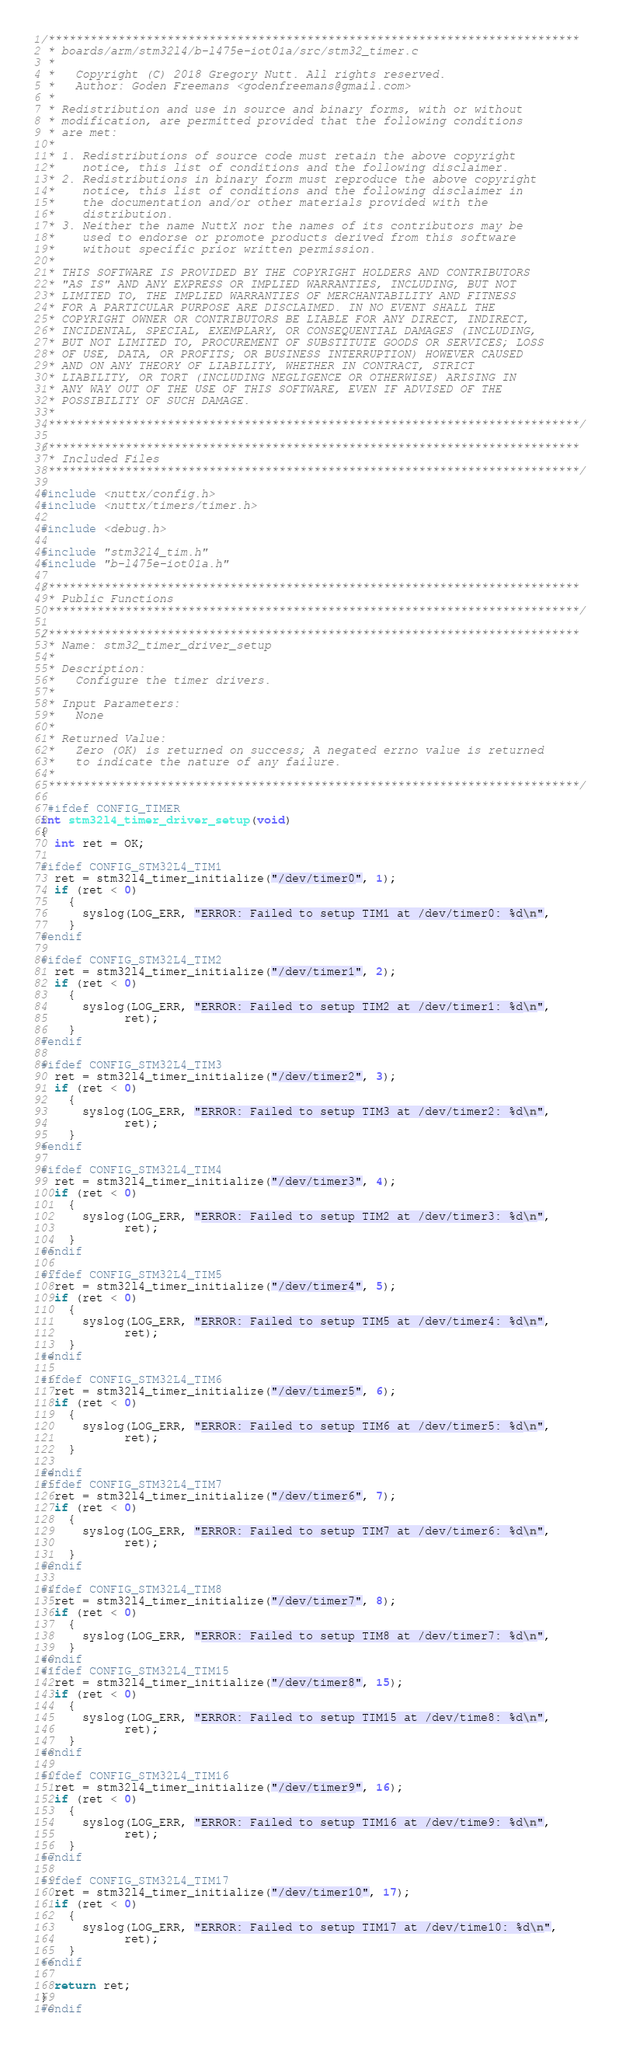<code> <loc_0><loc_0><loc_500><loc_500><_C_>/****************************************************************************
 * boards/arm/stm32l4/b-l475e-iot01a/src/stm32_timer.c
 *
 *   Copyright (C) 2018 Gregory Nutt. All rights reserved.
 *   Author: Goden Freemans <godenfreemans@gmail.com>
 *
 * Redistribution and use in source and binary forms, with or without
 * modification, are permitted provided that the following conditions
 * are met:
 *
 * 1. Redistributions of source code must retain the above copyright
 *    notice, this list of conditions and the following disclaimer.
 * 2. Redistributions in binary form must reproduce the above copyright
 *    notice, this list of conditions and the following disclaimer in
 *    the documentation and/or other materials provided with the
 *    distribution.
 * 3. Neither the name NuttX nor the names of its contributors may be
 *    used to endorse or promote products derived from this software
 *    without specific prior written permission.
 *
 * THIS SOFTWARE IS PROVIDED BY THE COPYRIGHT HOLDERS AND CONTRIBUTORS
 * "AS IS" AND ANY EXPRESS OR IMPLIED WARRANTIES, INCLUDING, BUT NOT
 * LIMITED TO, THE IMPLIED WARRANTIES OF MERCHANTABILITY AND FITNESS
 * FOR A PARTICULAR PURPOSE ARE DISCLAIMED. IN NO EVENT SHALL THE
 * COPYRIGHT OWNER OR CONTRIBUTORS BE LIABLE FOR ANY DIRECT, INDIRECT,
 * INCIDENTAL, SPECIAL, EXEMPLARY, OR CONSEQUENTIAL DAMAGES (INCLUDING,
 * BUT NOT LIMITED TO, PROCUREMENT OF SUBSTITUTE GOODS OR SERVICES; LOSS
 * OF USE, DATA, OR PROFITS; OR BUSINESS INTERRUPTION) HOWEVER CAUSED
 * AND ON ANY THEORY OF LIABILITY, WHETHER IN CONTRACT, STRICT
 * LIABILITY, OR TORT (INCLUDING NEGLIGENCE OR OTHERWISE) ARISING IN
 * ANY WAY OUT OF THE USE OF THIS SOFTWARE, EVEN IF ADVISED OF THE
 * POSSIBILITY OF SUCH DAMAGE.
 *
 ****************************************************************************/

/****************************************************************************
 * Included Files
 ****************************************************************************/

#include <nuttx/config.h>
#include <nuttx/timers/timer.h>

#include <debug.h>

#include "stm32l4_tim.h"
#include "b-l475e-iot01a.h"

/****************************************************************************
 * Public Functions
 ****************************************************************************/

/****************************************************************************
 * Name: stm32_timer_driver_setup
 *
 * Description:
 *   Configure the timer drivers.
 *
 * Input Parameters:
 *   None
 *
 * Returned Value:
 *   Zero (OK) is returned on success; A negated errno value is returned
 *   to indicate the nature of any failure.
 *
 ****************************************************************************/

 #ifdef CONFIG_TIMER
int stm32l4_timer_driver_setup(void)
{
  int ret = OK;

#ifdef CONFIG_STM32L4_TIM1
  ret = stm32l4_timer_initialize("/dev/timer0", 1);
  if (ret < 0)
    {
      syslog(LOG_ERR, "ERROR: Failed to setup TIM1 at /dev/timer0: %d\n",
    }
#endif

#ifdef CONFIG_STM32L4_TIM2
  ret = stm32l4_timer_initialize("/dev/timer1", 2);
  if (ret < 0)
    {
      syslog(LOG_ERR, "ERROR: Failed to setup TIM2 at /dev/timer1: %d\n",
            ret);
    }
#endif

#ifdef CONFIG_STM32L4_TIM3
  ret = stm32l4_timer_initialize("/dev/timer2", 3);
  if (ret < 0)
    {
      syslog(LOG_ERR, "ERROR: Failed to setup TIM3 at /dev/timer2: %d\n",
            ret);
    }
#endif

#ifdef CONFIG_STM32L4_TIM4
  ret = stm32l4_timer_initialize("/dev/timer3", 4);
  if (ret < 0)
    {
      syslog(LOG_ERR, "ERROR: Failed to setup TIM2 at /dev/timer3: %d\n",
            ret);
    }
#endif

#ifdef CONFIG_STM32L4_TIM5
  ret = stm32l4_timer_initialize("/dev/timer4", 5);
  if (ret < 0)
    {
      syslog(LOG_ERR, "ERROR: Failed to setup TIM5 at /dev/timer4: %d\n",
            ret);
    }
#endif

#ifdef CONFIG_STM32L4_TIM6
  ret = stm32l4_timer_initialize("/dev/timer5", 6);
  if (ret < 0)
    {
      syslog(LOG_ERR, "ERROR: Failed to setup TIM6 at /dev/timer5: %d\n",
            ret);
    }
    
#endif
#ifdef CONFIG_STM32L4_TIM7
  ret = stm32l4_timer_initialize("/dev/timer6", 7);
  if (ret < 0)
    {
      syslog(LOG_ERR, "ERROR: Failed to setup TIM7 at /dev/timer6: %d\n",
            ret);
    }
#endif

#ifdef CONFIG_STM32L4_TIM8
  ret = stm32l4_timer_initialize("/dev/timer7", 8);
  if (ret < 0)
    {
      syslog(LOG_ERR, "ERROR: Failed to setup TIM8 at /dev/timer7: %d\n",
    }
#endif
#ifdef CONFIG_STM32L4_TIM15
  ret = stm32l4_timer_initialize("/dev/timer8", 15);
  if (ret < 0)
    {
      syslog(LOG_ERR, "ERROR: Failed to setup TIM15 at /dev/time8: %d\n",
            ret);
    }
#endif

#ifdef CONFIG_STM32L4_TIM16
  ret = stm32l4_timer_initialize("/dev/timer9", 16);
  if (ret < 0)
    {
      syslog(LOG_ERR, "ERROR: Failed to setup TIM16 at /dev/time9: %d\n",
            ret);
    }
#endif

#ifdef CONFIG_STM32L4_TIM17
  ret = stm32l4_timer_initialize("/dev/timer10", 17);
  if (ret < 0)
    {
      syslog(LOG_ERR, "ERROR: Failed to setup TIM17 at /dev/time10: %d\n",
            ret);
    }
#endif

  return ret;
}
#endif
</code> 